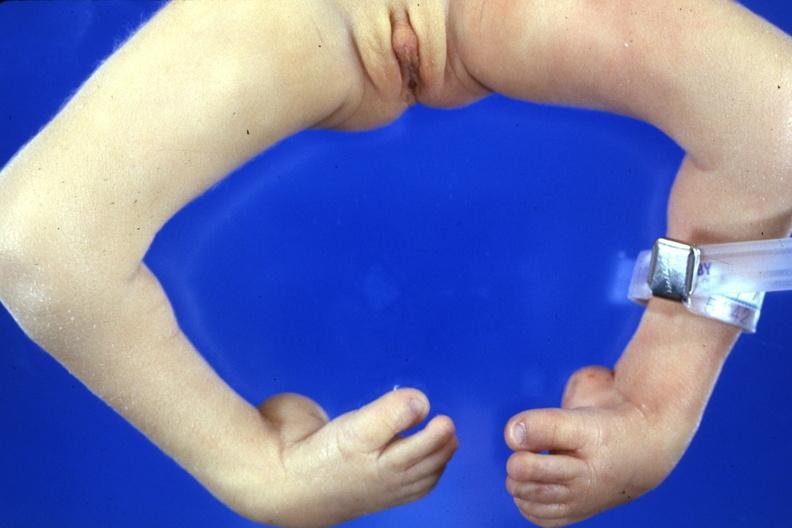what does this image show?
Answer the question using a single word or phrase. Club feet with marked talipes equinovarus 